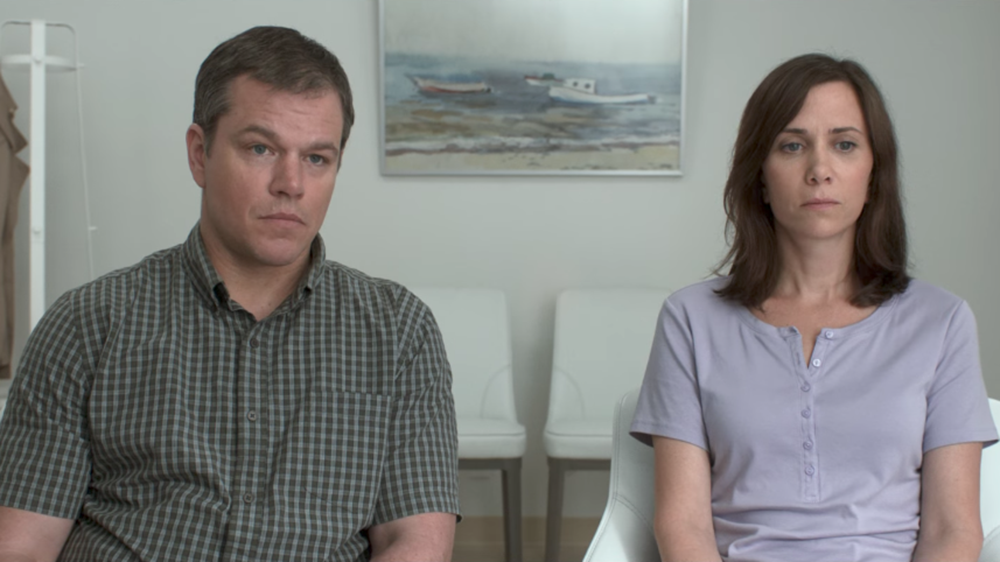What do you see happening in this image? In this image, two individuals are seated side by side in what appears to be a stark and minimalist room. The individuals, wearing a gray polo shirt and a lavender blouse respectively, seem contemplative and are looking in a direction other than the camera. The room's plain white walls and the presence of a painting of a boat hanging behind them create a contrast with their more colorful clothing. This composition conveys a sense of quiet introspection or a serious, possibly emotional, moment being shared between the two. 